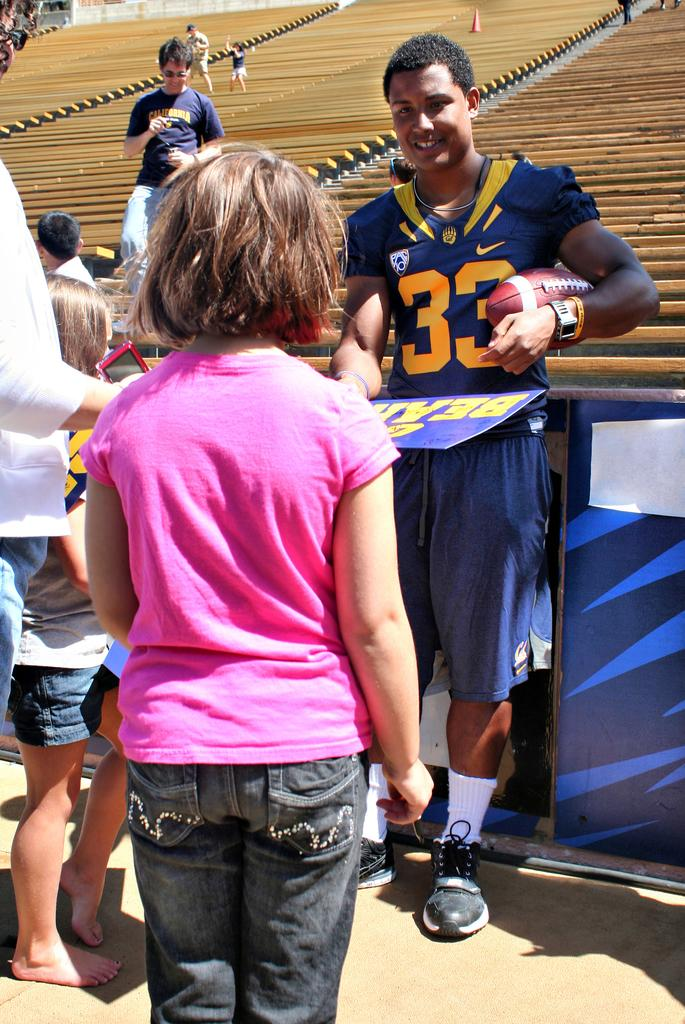<image>
Present a compact description of the photo's key features. player 33 with a pac10 patch on his jersey talking to a child 